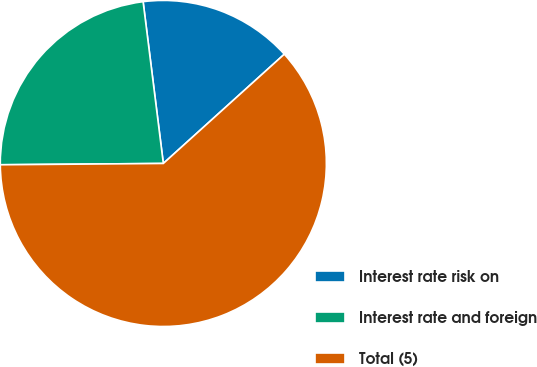Convert chart. <chart><loc_0><loc_0><loc_500><loc_500><pie_chart><fcel>Interest rate risk on<fcel>Interest rate and foreign<fcel>Total (5)<nl><fcel>15.29%<fcel>23.15%<fcel>61.57%<nl></chart> 